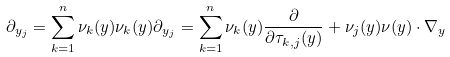Convert formula to latex. <formula><loc_0><loc_0><loc_500><loc_500>\partial _ { y _ { j } } = \sum _ { k = 1 } ^ { n } \nu _ { k } ( y ) \nu _ { k } ( y ) \partial _ { y _ { j } } = \sum _ { k = 1 } ^ { n } \nu _ { k } ( y ) \frac { \partial } { \partial \tau _ { k , j } ( y ) } + \nu _ { j } ( y ) \nu ( y ) \cdot \nabla _ { y }</formula> 